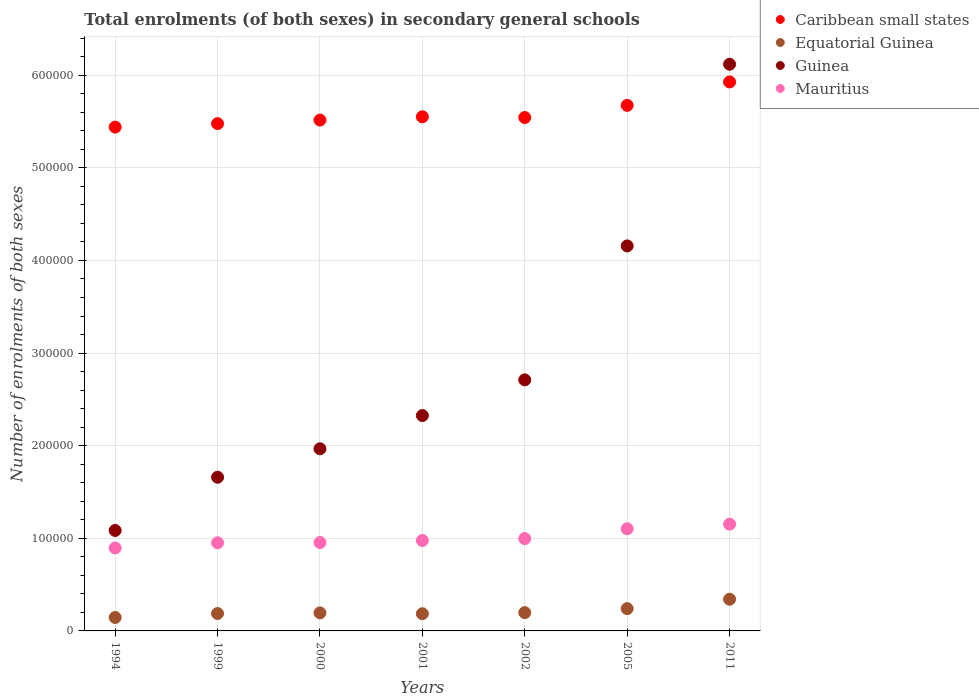How many different coloured dotlines are there?
Offer a terse response. 4. Is the number of dotlines equal to the number of legend labels?
Give a very brief answer. Yes. What is the number of enrolments in secondary schools in Equatorial Guinea in 1994?
Keep it short and to the point. 1.45e+04. Across all years, what is the maximum number of enrolments in secondary schools in Mauritius?
Your answer should be very brief. 1.15e+05. Across all years, what is the minimum number of enrolments in secondary schools in Guinea?
Your answer should be compact. 1.08e+05. What is the total number of enrolments in secondary schools in Equatorial Guinea in the graph?
Your answer should be very brief. 1.49e+05. What is the difference between the number of enrolments in secondary schools in Caribbean small states in 1999 and that in 2002?
Offer a very short reply. -6573.19. What is the difference between the number of enrolments in secondary schools in Mauritius in 2000 and the number of enrolments in secondary schools in Guinea in 2001?
Offer a terse response. -1.37e+05. What is the average number of enrolments in secondary schools in Caribbean small states per year?
Provide a succinct answer. 5.59e+05. In the year 1994, what is the difference between the number of enrolments in secondary schools in Equatorial Guinea and number of enrolments in secondary schools in Mauritius?
Ensure brevity in your answer.  -7.51e+04. In how many years, is the number of enrolments in secondary schools in Guinea greater than 240000?
Your answer should be very brief. 3. What is the ratio of the number of enrolments in secondary schools in Caribbean small states in 2001 to that in 2002?
Your answer should be compact. 1. What is the difference between the highest and the second highest number of enrolments in secondary schools in Mauritius?
Offer a very short reply. 5002. What is the difference between the highest and the lowest number of enrolments in secondary schools in Caribbean small states?
Your answer should be compact. 4.88e+04. Does the number of enrolments in secondary schools in Mauritius monotonically increase over the years?
Provide a short and direct response. Yes. How many dotlines are there?
Provide a succinct answer. 4. What is the difference between two consecutive major ticks on the Y-axis?
Your answer should be very brief. 1.00e+05. Does the graph contain any zero values?
Give a very brief answer. No. Does the graph contain grids?
Offer a terse response. Yes. How many legend labels are there?
Your answer should be compact. 4. How are the legend labels stacked?
Offer a very short reply. Vertical. What is the title of the graph?
Offer a terse response. Total enrolments (of both sexes) in secondary general schools. Does "Middle East & North Africa (all income levels)" appear as one of the legend labels in the graph?
Offer a terse response. No. What is the label or title of the Y-axis?
Ensure brevity in your answer.  Number of enrolments of both sexes. What is the Number of enrolments of both sexes in Caribbean small states in 1994?
Offer a terse response. 5.44e+05. What is the Number of enrolments of both sexes of Equatorial Guinea in 1994?
Ensure brevity in your answer.  1.45e+04. What is the Number of enrolments of both sexes of Guinea in 1994?
Your response must be concise. 1.08e+05. What is the Number of enrolments of both sexes of Mauritius in 1994?
Keep it short and to the point. 8.96e+04. What is the Number of enrolments of both sexes of Caribbean small states in 1999?
Your answer should be compact. 5.48e+05. What is the Number of enrolments of both sexes of Equatorial Guinea in 1999?
Give a very brief answer. 1.88e+04. What is the Number of enrolments of both sexes in Guinea in 1999?
Offer a terse response. 1.66e+05. What is the Number of enrolments of both sexes in Mauritius in 1999?
Make the answer very short. 9.52e+04. What is the Number of enrolments of both sexes of Caribbean small states in 2000?
Offer a very short reply. 5.52e+05. What is the Number of enrolments of both sexes in Equatorial Guinea in 2000?
Give a very brief answer. 1.95e+04. What is the Number of enrolments of both sexes in Guinea in 2000?
Your answer should be very brief. 1.97e+05. What is the Number of enrolments of both sexes in Mauritius in 2000?
Offer a very short reply. 9.54e+04. What is the Number of enrolments of both sexes in Caribbean small states in 2001?
Provide a short and direct response. 5.55e+05. What is the Number of enrolments of both sexes in Equatorial Guinea in 2001?
Your answer should be compact. 1.86e+04. What is the Number of enrolments of both sexes in Guinea in 2001?
Offer a terse response. 2.33e+05. What is the Number of enrolments of both sexes in Mauritius in 2001?
Give a very brief answer. 9.76e+04. What is the Number of enrolments of both sexes in Caribbean small states in 2002?
Offer a very short reply. 5.54e+05. What is the Number of enrolments of both sexes in Equatorial Guinea in 2002?
Your answer should be compact. 1.97e+04. What is the Number of enrolments of both sexes of Guinea in 2002?
Ensure brevity in your answer.  2.71e+05. What is the Number of enrolments of both sexes of Mauritius in 2002?
Your response must be concise. 9.97e+04. What is the Number of enrolments of both sexes of Caribbean small states in 2005?
Give a very brief answer. 5.67e+05. What is the Number of enrolments of both sexes in Equatorial Guinea in 2005?
Provide a succinct answer. 2.41e+04. What is the Number of enrolments of both sexes in Guinea in 2005?
Offer a very short reply. 4.16e+05. What is the Number of enrolments of both sexes of Mauritius in 2005?
Your response must be concise. 1.10e+05. What is the Number of enrolments of both sexes of Caribbean small states in 2011?
Keep it short and to the point. 5.93e+05. What is the Number of enrolments of both sexes of Equatorial Guinea in 2011?
Keep it short and to the point. 3.42e+04. What is the Number of enrolments of both sexes in Guinea in 2011?
Offer a terse response. 6.12e+05. What is the Number of enrolments of both sexes of Mauritius in 2011?
Offer a very short reply. 1.15e+05. Across all years, what is the maximum Number of enrolments of both sexes of Caribbean small states?
Give a very brief answer. 5.93e+05. Across all years, what is the maximum Number of enrolments of both sexes of Equatorial Guinea?
Make the answer very short. 3.42e+04. Across all years, what is the maximum Number of enrolments of both sexes of Guinea?
Offer a very short reply. 6.12e+05. Across all years, what is the maximum Number of enrolments of both sexes of Mauritius?
Provide a succinct answer. 1.15e+05. Across all years, what is the minimum Number of enrolments of both sexes of Caribbean small states?
Offer a very short reply. 5.44e+05. Across all years, what is the minimum Number of enrolments of both sexes in Equatorial Guinea?
Make the answer very short. 1.45e+04. Across all years, what is the minimum Number of enrolments of both sexes in Guinea?
Your answer should be very brief. 1.08e+05. Across all years, what is the minimum Number of enrolments of both sexes in Mauritius?
Ensure brevity in your answer.  8.96e+04. What is the total Number of enrolments of both sexes in Caribbean small states in the graph?
Offer a very short reply. 3.91e+06. What is the total Number of enrolments of both sexes in Equatorial Guinea in the graph?
Provide a succinct answer. 1.49e+05. What is the total Number of enrolments of both sexes of Guinea in the graph?
Give a very brief answer. 2.00e+06. What is the total Number of enrolments of both sexes in Mauritius in the graph?
Give a very brief answer. 7.03e+05. What is the difference between the Number of enrolments of both sexes of Caribbean small states in 1994 and that in 1999?
Your answer should be compact. -3752. What is the difference between the Number of enrolments of both sexes in Equatorial Guinea in 1994 and that in 1999?
Make the answer very short. -4291. What is the difference between the Number of enrolments of both sexes in Guinea in 1994 and that in 1999?
Give a very brief answer. -5.75e+04. What is the difference between the Number of enrolments of both sexes in Mauritius in 1994 and that in 1999?
Your answer should be very brief. -5606. What is the difference between the Number of enrolments of both sexes in Caribbean small states in 1994 and that in 2000?
Offer a terse response. -7582. What is the difference between the Number of enrolments of both sexes in Equatorial Guinea in 1994 and that in 2000?
Offer a terse response. -4972. What is the difference between the Number of enrolments of both sexes in Guinea in 1994 and that in 2000?
Offer a very short reply. -8.82e+04. What is the difference between the Number of enrolments of both sexes of Mauritius in 1994 and that in 2000?
Provide a succinct answer. -5867. What is the difference between the Number of enrolments of both sexes of Caribbean small states in 1994 and that in 2001?
Give a very brief answer. -1.11e+04. What is the difference between the Number of enrolments of both sexes of Equatorial Guinea in 1994 and that in 2001?
Offer a very short reply. -4044. What is the difference between the Number of enrolments of both sexes of Guinea in 1994 and that in 2001?
Your answer should be compact. -1.24e+05. What is the difference between the Number of enrolments of both sexes in Mauritius in 1994 and that in 2001?
Provide a succinct answer. -8066. What is the difference between the Number of enrolments of both sexes in Caribbean small states in 1994 and that in 2002?
Offer a very short reply. -1.03e+04. What is the difference between the Number of enrolments of both sexes of Equatorial Guinea in 1994 and that in 2002?
Give a very brief answer. -5237. What is the difference between the Number of enrolments of both sexes in Guinea in 1994 and that in 2002?
Give a very brief answer. -1.63e+05. What is the difference between the Number of enrolments of both sexes in Mauritius in 1994 and that in 2002?
Your response must be concise. -1.01e+04. What is the difference between the Number of enrolments of both sexes in Caribbean small states in 1994 and that in 2005?
Your answer should be compact. -2.35e+04. What is the difference between the Number of enrolments of both sexes in Equatorial Guinea in 1994 and that in 2005?
Keep it short and to the point. -9553. What is the difference between the Number of enrolments of both sexes of Guinea in 1994 and that in 2005?
Your answer should be very brief. -3.07e+05. What is the difference between the Number of enrolments of both sexes in Mauritius in 1994 and that in 2005?
Provide a succinct answer. -2.07e+04. What is the difference between the Number of enrolments of both sexes in Caribbean small states in 1994 and that in 2011?
Keep it short and to the point. -4.88e+04. What is the difference between the Number of enrolments of both sexes of Equatorial Guinea in 1994 and that in 2011?
Your response must be concise. -1.97e+04. What is the difference between the Number of enrolments of both sexes in Guinea in 1994 and that in 2011?
Provide a succinct answer. -5.03e+05. What is the difference between the Number of enrolments of both sexes in Mauritius in 1994 and that in 2011?
Ensure brevity in your answer.  -2.57e+04. What is the difference between the Number of enrolments of both sexes of Caribbean small states in 1999 and that in 2000?
Provide a short and direct response. -3830. What is the difference between the Number of enrolments of both sexes in Equatorial Guinea in 1999 and that in 2000?
Make the answer very short. -681. What is the difference between the Number of enrolments of both sexes of Guinea in 1999 and that in 2000?
Your response must be concise. -3.07e+04. What is the difference between the Number of enrolments of both sexes of Mauritius in 1999 and that in 2000?
Make the answer very short. -261. What is the difference between the Number of enrolments of both sexes in Caribbean small states in 1999 and that in 2001?
Your answer should be very brief. -7373.25. What is the difference between the Number of enrolments of both sexes of Equatorial Guinea in 1999 and that in 2001?
Give a very brief answer. 247. What is the difference between the Number of enrolments of both sexes in Guinea in 1999 and that in 2001?
Offer a terse response. -6.66e+04. What is the difference between the Number of enrolments of both sexes of Mauritius in 1999 and that in 2001?
Offer a very short reply. -2460. What is the difference between the Number of enrolments of both sexes in Caribbean small states in 1999 and that in 2002?
Provide a short and direct response. -6573.19. What is the difference between the Number of enrolments of both sexes of Equatorial Guinea in 1999 and that in 2002?
Make the answer very short. -946. What is the difference between the Number of enrolments of both sexes of Guinea in 1999 and that in 2002?
Offer a very short reply. -1.05e+05. What is the difference between the Number of enrolments of both sexes in Mauritius in 1999 and that in 2002?
Your response must be concise. -4500. What is the difference between the Number of enrolments of both sexes in Caribbean small states in 1999 and that in 2005?
Make the answer very short. -1.97e+04. What is the difference between the Number of enrolments of both sexes in Equatorial Guinea in 1999 and that in 2005?
Your response must be concise. -5262. What is the difference between the Number of enrolments of both sexes in Guinea in 1999 and that in 2005?
Ensure brevity in your answer.  -2.50e+05. What is the difference between the Number of enrolments of both sexes of Mauritius in 1999 and that in 2005?
Make the answer very short. -1.51e+04. What is the difference between the Number of enrolments of both sexes in Caribbean small states in 1999 and that in 2011?
Ensure brevity in your answer.  -4.50e+04. What is the difference between the Number of enrolments of both sexes in Equatorial Guinea in 1999 and that in 2011?
Provide a succinct answer. -1.54e+04. What is the difference between the Number of enrolments of both sexes of Guinea in 1999 and that in 2011?
Offer a terse response. -4.46e+05. What is the difference between the Number of enrolments of both sexes in Mauritius in 1999 and that in 2011?
Provide a short and direct response. -2.01e+04. What is the difference between the Number of enrolments of both sexes in Caribbean small states in 2000 and that in 2001?
Your answer should be compact. -3543.25. What is the difference between the Number of enrolments of both sexes of Equatorial Guinea in 2000 and that in 2001?
Provide a succinct answer. 928. What is the difference between the Number of enrolments of both sexes in Guinea in 2000 and that in 2001?
Provide a succinct answer. -3.59e+04. What is the difference between the Number of enrolments of both sexes of Mauritius in 2000 and that in 2001?
Give a very brief answer. -2199. What is the difference between the Number of enrolments of both sexes in Caribbean small states in 2000 and that in 2002?
Make the answer very short. -2743.19. What is the difference between the Number of enrolments of both sexes in Equatorial Guinea in 2000 and that in 2002?
Keep it short and to the point. -265. What is the difference between the Number of enrolments of both sexes of Guinea in 2000 and that in 2002?
Offer a very short reply. -7.44e+04. What is the difference between the Number of enrolments of both sexes in Mauritius in 2000 and that in 2002?
Your response must be concise. -4239. What is the difference between the Number of enrolments of both sexes in Caribbean small states in 2000 and that in 2005?
Make the answer very short. -1.59e+04. What is the difference between the Number of enrolments of both sexes in Equatorial Guinea in 2000 and that in 2005?
Your response must be concise. -4581. What is the difference between the Number of enrolments of both sexes in Guinea in 2000 and that in 2005?
Give a very brief answer. -2.19e+05. What is the difference between the Number of enrolments of both sexes in Mauritius in 2000 and that in 2005?
Offer a very short reply. -1.48e+04. What is the difference between the Number of enrolments of both sexes of Caribbean small states in 2000 and that in 2011?
Offer a terse response. -4.12e+04. What is the difference between the Number of enrolments of both sexes in Equatorial Guinea in 2000 and that in 2011?
Keep it short and to the point. -1.48e+04. What is the difference between the Number of enrolments of both sexes of Guinea in 2000 and that in 2011?
Keep it short and to the point. -4.15e+05. What is the difference between the Number of enrolments of both sexes of Mauritius in 2000 and that in 2011?
Your answer should be compact. -1.98e+04. What is the difference between the Number of enrolments of both sexes of Caribbean small states in 2001 and that in 2002?
Provide a succinct answer. 800.06. What is the difference between the Number of enrolments of both sexes in Equatorial Guinea in 2001 and that in 2002?
Offer a very short reply. -1193. What is the difference between the Number of enrolments of both sexes in Guinea in 2001 and that in 2002?
Your response must be concise. -3.85e+04. What is the difference between the Number of enrolments of both sexes in Mauritius in 2001 and that in 2002?
Keep it short and to the point. -2040. What is the difference between the Number of enrolments of both sexes of Caribbean small states in 2001 and that in 2005?
Keep it short and to the point. -1.23e+04. What is the difference between the Number of enrolments of both sexes of Equatorial Guinea in 2001 and that in 2005?
Your response must be concise. -5509. What is the difference between the Number of enrolments of both sexes in Guinea in 2001 and that in 2005?
Make the answer very short. -1.83e+05. What is the difference between the Number of enrolments of both sexes in Mauritius in 2001 and that in 2005?
Give a very brief answer. -1.26e+04. What is the difference between the Number of enrolments of both sexes in Caribbean small states in 2001 and that in 2011?
Your response must be concise. -3.77e+04. What is the difference between the Number of enrolments of both sexes in Equatorial Guinea in 2001 and that in 2011?
Give a very brief answer. -1.57e+04. What is the difference between the Number of enrolments of both sexes in Guinea in 2001 and that in 2011?
Offer a terse response. -3.79e+05. What is the difference between the Number of enrolments of both sexes in Mauritius in 2001 and that in 2011?
Make the answer very short. -1.76e+04. What is the difference between the Number of enrolments of both sexes in Caribbean small states in 2002 and that in 2005?
Your answer should be compact. -1.31e+04. What is the difference between the Number of enrolments of both sexes of Equatorial Guinea in 2002 and that in 2005?
Your answer should be compact. -4316. What is the difference between the Number of enrolments of both sexes of Guinea in 2002 and that in 2005?
Your answer should be compact. -1.45e+05. What is the difference between the Number of enrolments of both sexes of Mauritius in 2002 and that in 2005?
Offer a very short reply. -1.06e+04. What is the difference between the Number of enrolments of both sexes of Caribbean small states in 2002 and that in 2011?
Your response must be concise. -3.85e+04. What is the difference between the Number of enrolments of both sexes in Equatorial Guinea in 2002 and that in 2011?
Offer a terse response. -1.45e+04. What is the difference between the Number of enrolments of both sexes in Guinea in 2002 and that in 2011?
Your answer should be compact. -3.41e+05. What is the difference between the Number of enrolments of both sexes of Mauritius in 2002 and that in 2011?
Your answer should be compact. -1.56e+04. What is the difference between the Number of enrolments of both sexes in Caribbean small states in 2005 and that in 2011?
Your answer should be very brief. -2.53e+04. What is the difference between the Number of enrolments of both sexes in Equatorial Guinea in 2005 and that in 2011?
Provide a succinct answer. -1.02e+04. What is the difference between the Number of enrolments of both sexes of Guinea in 2005 and that in 2011?
Provide a succinct answer. -1.96e+05. What is the difference between the Number of enrolments of both sexes in Mauritius in 2005 and that in 2011?
Your answer should be compact. -5002. What is the difference between the Number of enrolments of both sexes of Caribbean small states in 1994 and the Number of enrolments of both sexes of Equatorial Guinea in 1999?
Offer a very short reply. 5.25e+05. What is the difference between the Number of enrolments of both sexes of Caribbean small states in 1994 and the Number of enrolments of both sexes of Guinea in 1999?
Provide a succinct answer. 3.78e+05. What is the difference between the Number of enrolments of both sexes of Caribbean small states in 1994 and the Number of enrolments of both sexes of Mauritius in 1999?
Ensure brevity in your answer.  4.49e+05. What is the difference between the Number of enrolments of both sexes in Equatorial Guinea in 1994 and the Number of enrolments of both sexes in Guinea in 1999?
Provide a short and direct response. -1.51e+05. What is the difference between the Number of enrolments of both sexes of Equatorial Guinea in 1994 and the Number of enrolments of both sexes of Mauritius in 1999?
Provide a succinct answer. -8.07e+04. What is the difference between the Number of enrolments of both sexes of Guinea in 1994 and the Number of enrolments of both sexes of Mauritius in 1999?
Provide a succinct answer. 1.33e+04. What is the difference between the Number of enrolments of both sexes of Caribbean small states in 1994 and the Number of enrolments of both sexes of Equatorial Guinea in 2000?
Offer a terse response. 5.25e+05. What is the difference between the Number of enrolments of both sexes in Caribbean small states in 1994 and the Number of enrolments of both sexes in Guinea in 2000?
Offer a very short reply. 3.47e+05. What is the difference between the Number of enrolments of both sexes of Caribbean small states in 1994 and the Number of enrolments of both sexes of Mauritius in 2000?
Provide a succinct answer. 4.49e+05. What is the difference between the Number of enrolments of both sexes of Equatorial Guinea in 1994 and the Number of enrolments of both sexes of Guinea in 2000?
Offer a very short reply. -1.82e+05. What is the difference between the Number of enrolments of both sexes in Equatorial Guinea in 1994 and the Number of enrolments of both sexes in Mauritius in 2000?
Provide a short and direct response. -8.09e+04. What is the difference between the Number of enrolments of both sexes in Guinea in 1994 and the Number of enrolments of both sexes in Mauritius in 2000?
Your answer should be compact. 1.30e+04. What is the difference between the Number of enrolments of both sexes in Caribbean small states in 1994 and the Number of enrolments of both sexes in Equatorial Guinea in 2001?
Offer a terse response. 5.25e+05. What is the difference between the Number of enrolments of both sexes in Caribbean small states in 1994 and the Number of enrolments of both sexes in Guinea in 2001?
Provide a succinct answer. 3.11e+05. What is the difference between the Number of enrolments of both sexes of Caribbean small states in 1994 and the Number of enrolments of both sexes of Mauritius in 2001?
Provide a short and direct response. 4.46e+05. What is the difference between the Number of enrolments of both sexes of Equatorial Guinea in 1994 and the Number of enrolments of both sexes of Guinea in 2001?
Provide a succinct answer. -2.18e+05. What is the difference between the Number of enrolments of both sexes in Equatorial Guinea in 1994 and the Number of enrolments of both sexes in Mauritius in 2001?
Offer a very short reply. -8.31e+04. What is the difference between the Number of enrolments of both sexes of Guinea in 1994 and the Number of enrolments of both sexes of Mauritius in 2001?
Give a very brief answer. 1.08e+04. What is the difference between the Number of enrolments of both sexes in Caribbean small states in 1994 and the Number of enrolments of both sexes in Equatorial Guinea in 2002?
Your answer should be very brief. 5.24e+05. What is the difference between the Number of enrolments of both sexes of Caribbean small states in 1994 and the Number of enrolments of both sexes of Guinea in 2002?
Ensure brevity in your answer.  2.73e+05. What is the difference between the Number of enrolments of both sexes in Caribbean small states in 1994 and the Number of enrolments of both sexes in Mauritius in 2002?
Give a very brief answer. 4.44e+05. What is the difference between the Number of enrolments of both sexes of Equatorial Guinea in 1994 and the Number of enrolments of both sexes of Guinea in 2002?
Provide a short and direct response. -2.57e+05. What is the difference between the Number of enrolments of both sexes in Equatorial Guinea in 1994 and the Number of enrolments of both sexes in Mauritius in 2002?
Keep it short and to the point. -8.52e+04. What is the difference between the Number of enrolments of both sexes in Guinea in 1994 and the Number of enrolments of both sexes in Mauritius in 2002?
Make the answer very short. 8772. What is the difference between the Number of enrolments of both sexes of Caribbean small states in 1994 and the Number of enrolments of both sexes of Equatorial Guinea in 2005?
Ensure brevity in your answer.  5.20e+05. What is the difference between the Number of enrolments of both sexes in Caribbean small states in 1994 and the Number of enrolments of both sexes in Guinea in 2005?
Keep it short and to the point. 1.28e+05. What is the difference between the Number of enrolments of both sexes in Caribbean small states in 1994 and the Number of enrolments of both sexes in Mauritius in 2005?
Make the answer very short. 4.34e+05. What is the difference between the Number of enrolments of both sexes of Equatorial Guinea in 1994 and the Number of enrolments of both sexes of Guinea in 2005?
Your response must be concise. -4.01e+05. What is the difference between the Number of enrolments of both sexes in Equatorial Guinea in 1994 and the Number of enrolments of both sexes in Mauritius in 2005?
Make the answer very short. -9.58e+04. What is the difference between the Number of enrolments of both sexes of Guinea in 1994 and the Number of enrolments of both sexes of Mauritius in 2005?
Ensure brevity in your answer.  -1828. What is the difference between the Number of enrolments of both sexes of Caribbean small states in 1994 and the Number of enrolments of both sexes of Equatorial Guinea in 2011?
Ensure brevity in your answer.  5.10e+05. What is the difference between the Number of enrolments of both sexes of Caribbean small states in 1994 and the Number of enrolments of both sexes of Guinea in 2011?
Provide a short and direct response. -6.79e+04. What is the difference between the Number of enrolments of both sexes in Caribbean small states in 1994 and the Number of enrolments of both sexes in Mauritius in 2011?
Provide a short and direct response. 4.29e+05. What is the difference between the Number of enrolments of both sexes in Equatorial Guinea in 1994 and the Number of enrolments of both sexes in Guinea in 2011?
Offer a terse response. -5.97e+05. What is the difference between the Number of enrolments of both sexes of Equatorial Guinea in 1994 and the Number of enrolments of both sexes of Mauritius in 2011?
Ensure brevity in your answer.  -1.01e+05. What is the difference between the Number of enrolments of both sexes of Guinea in 1994 and the Number of enrolments of both sexes of Mauritius in 2011?
Make the answer very short. -6830. What is the difference between the Number of enrolments of both sexes of Caribbean small states in 1999 and the Number of enrolments of both sexes of Equatorial Guinea in 2000?
Give a very brief answer. 5.28e+05. What is the difference between the Number of enrolments of both sexes in Caribbean small states in 1999 and the Number of enrolments of both sexes in Guinea in 2000?
Give a very brief answer. 3.51e+05. What is the difference between the Number of enrolments of both sexes in Caribbean small states in 1999 and the Number of enrolments of both sexes in Mauritius in 2000?
Offer a very short reply. 4.52e+05. What is the difference between the Number of enrolments of both sexes in Equatorial Guinea in 1999 and the Number of enrolments of both sexes in Guinea in 2000?
Ensure brevity in your answer.  -1.78e+05. What is the difference between the Number of enrolments of both sexes in Equatorial Guinea in 1999 and the Number of enrolments of both sexes in Mauritius in 2000?
Offer a very short reply. -7.66e+04. What is the difference between the Number of enrolments of both sexes in Guinea in 1999 and the Number of enrolments of both sexes in Mauritius in 2000?
Keep it short and to the point. 7.05e+04. What is the difference between the Number of enrolments of both sexes in Caribbean small states in 1999 and the Number of enrolments of both sexes in Equatorial Guinea in 2001?
Ensure brevity in your answer.  5.29e+05. What is the difference between the Number of enrolments of both sexes in Caribbean small states in 1999 and the Number of enrolments of both sexes in Guinea in 2001?
Provide a short and direct response. 3.15e+05. What is the difference between the Number of enrolments of both sexes in Caribbean small states in 1999 and the Number of enrolments of both sexes in Mauritius in 2001?
Ensure brevity in your answer.  4.50e+05. What is the difference between the Number of enrolments of both sexes in Equatorial Guinea in 1999 and the Number of enrolments of both sexes in Guinea in 2001?
Offer a very short reply. -2.14e+05. What is the difference between the Number of enrolments of both sexes of Equatorial Guinea in 1999 and the Number of enrolments of both sexes of Mauritius in 2001?
Provide a short and direct response. -7.88e+04. What is the difference between the Number of enrolments of both sexes of Guinea in 1999 and the Number of enrolments of both sexes of Mauritius in 2001?
Offer a very short reply. 6.83e+04. What is the difference between the Number of enrolments of both sexes of Caribbean small states in 1999 and the Number of enrolments of both sexes of Equatorial Guinea in 2002?
Offer a very short reply. 5.28e+05. What is the difference between the Number of enrolments of both sexes of Caribbean small states in 1999 and the Number of enrolments of both sexes of Guinea in 2002?
Your response must be concise. 2.77e+05. What is the difference between the Number of enrolments of both sexes in Caribbean small states in 1999 and the Number of enrolments of both sexes in Mauritius in 2002?
Your answer should be compact. 4.48e+05. What is the difference between the Number of enrolments of both sexes in Equatorial Guinea in 1999 and the Number of enrolments of both sexes in Guinea in 2002?
Ensure brevity in your answer.  -2.52e+05. What is the difference between the Number of enrolments of both sexes of Equatorial Guinea in 1999 and the Number of enrolments of both sexes of Mauritius in 2002?
Your answer should be very brief. -8.09e+04. What is the difference between the Number of enrolments of both sexes in Guinea in 1999 and the Number of enrolments of both sexes in Mauritius in 2002?
Provide a succinct answer. 6.62e+04. What is the difference between the Number of enrolments of both sexes of Caribbean small states in 1999 and the Number of enrolments of both sexes of Equatorial Guinea in 2005?
Your answer should be very brief. 5.24e+05. What is the difference between the Number of enrolments of both sexes of Caribbean small states in 1999 and the Number of enrolments of both sexes of Guinea in 2005?
Offer a terse response. 1.32e+05. What is the difference between the Number of enrolments of both sexes of Caribbean small states in 1999 and the Number of enrolments of both sexes of Mauritius in 2005?
Make the answer very short. 4.37e+05. What is the difference between the Number of enrolments of both sexes of Equatorial Guinea in 1999 and the Number of enrolments of both sexes of Guinea in 2005?
Make the answer very short. -3.97e+05. What is the difference between the Number of enrolments of both sexes in Equatorial Guinea in 1999 and the Number of enrolments of both sexes in Mauritius in 2005?
Offer a very short reply. -9.15e+04. What is the difference between the Number of enrolments of both sexes of Guinea in 1999 and the Number of enrolments of both sexes of Mauritius in 2005?
Ensure brevity in your answer.  5.56e+04. What is the difference between the Number of enrolments of both sexes in Caribbean small states in 1999 and the Number of enrolments of both sexes in Equatorial Guinea in 2011?
Your response must be concise. 5.14e+05. What is the difference between the Number of enrolments of both sexes of Caribbean small states in 1999 and the Number of enrolments of both sexes of Guinea in 2011?
Provide a succinct answer. -6.41e+04. What is the difference between the Number of enrolments of both sexes of Caribbean small states in 1999 and the Number of enrolments of both sexes of Mauritius in 2011?
Your answer should be compact. 4.32e+05. What is the difference between the Number of enrolments of both sexes of Equatorial Guinea in 1999 and the Number of enrolments of both sexes of Guinea in 2011?
Your answer should be very brief. -5.93e+05. What is the difference between the Number of enrolments of both sexes of Equatorial Guinea in 1999 and the Number of enrolments of both sexes of Mauritius in 2011?
Your answer should be very brief. -9.65e+04. What is the difference between the Number of enrolments of both sexes of Guinea in 1999 and the Number of enrolments of both sexes of Mauritius in 2011?
Provide a short and direct response. 5.06e+04. What is the difference between the Number of enrolments of both sexes of Caribbean small states in 2000 and the Number of enrolments of both sexes of Equatorial Guinea in 2001?
Provide a succinct answer. 5.33e+05. What is the difference between the Number of enrolments of both sexes in Caribbean small states in 2000 and the Number of enrolments of both sexes in Guinea in 2001?
Your response must be concise. 3.19e+05. What is the difference between the Number of enrolments of both sexes in Caribbean small states in 2000 and the Number of enrolments of both sexes in Mauritius in 2001?
Keep it short and to the point. 4.54e+05. What is the difference between the Number of enrolments of both sexes in Equatorial Guinea in 2000 and the Number of enrolments of both sexes in Guinea in 2001?
Your response must be concise. -2.13e+05. What is the difference between the Number of enrolments of both sexes of Equatorial Guinea in 2000 and the Number of enrolments of both sexes of Mauritius in 2001?
Make the answer very short. -7.82e+04. What is the difference between the Number of enrolments of both sexes of Guinea in 2000 and the Number of enrolments of both sexes of Mauritius in 2001?
Ensure brevity in your answer.  9.90e+04. What is the difference between the Number of enrolments of both sexes in Caribbean small states in 2000 and the Number of enrolments of both sexes in Equatorial Guinea in 2002?
Keep it short and to the point. 5.32e+05. What is the difference between the Number of enrolments of both sexes in Caribbean small states in 2000 and the Number of enrolments of both sexes in Guinea in 2002?
Provide a succinct answer. 2.80e+05. What is the difference between the Number of enrolments of both sexes of Caribbean small states in 2000 and the Number of enrolments of both sexes of Mauritius in 2002?
Your answer should be compact. 4.52e+05. What is the difference between the Number of enrolments of both sexes of Equatorial Guinea in 2000 and the Number of enrolments of both sexes of Guinea in 2002?
Keep it short and to the point. -2.52e+05. What is the difference between the Number of enrolments of both sexes of Equatorial Guinea in 2000 and the Number of enrolments of both sexes of Mauritius in 2002?
Provide a succinct answer. -8.02e+04. What is the difference between the Number of enrolments of both sexes in Guinea in 2000 and the Number of enrolments of both sexes in Mauritius in 2002?
Keep it short and to the point. 9.70e+04. What is the difference between the Number of enrolments of both sexes of Caribbean small states in 2000 and the Number of enrolments of both sexes of Equatorial Guinea in 2005?
Keep it short and to the point. 5.28e+05. What is the difference between the Number of enrolments of both sexes of Caribbean small states in 2000 and the Number of enrolments of both sexes of Guinea in 2005?
Your answer should be very brief. 1.36e+05. What is the difference between the Number of enrolments of both sexes in Caribbean small states in 2000 and the Number of enrolments of both sexes in Mauritius in 2005?
Your response must be concise. 4.41e+05. What is the difference between the Number of enrolments of both sexes in Equatorial Guinea in 2000 and the Number of enrolments of both sexes in Guinea in 2005?
Your answer should be compact. -3.96e+05. What is the difference between the Number of enrolments of both sexes in Equatorial Guinea in 2000 and the Number of enrolments of both sexes in Mauritius in 2005?
Provide a short and direct response. -9.08e+04. What is the difference between the Number of enrolments of both sexes in Guinea in 2000 and the Number of enrolments of both sexes in Mauritius in 2005?
Provide a short and direct response. 8.64e+04. What is the difference between the Number of enrolments of both sexes of Caribbean small states in 2000 and the Number of enrolments of both sexes of Equatorial Guinea in 2011?
Provide a succinct answer. 5.17e+05. What is the difference between the Number of enrolments of both sexes of Caribbean small states in 2000 and the Number of enrolments of both sexes of Guinea in 2011?
Provide a short and direct response. -6.03e+04. What is the difference between the Number of enrolments of both sexes of Caribbean small states in 2000 and the Number of enrolments of both sexes of Mauritius in 2011?
Your answer should be compact. 4.36e+05. What is the difference between the Number of enrolments of both sexes in Equatorial Guinea in 2000 and the Number of enrolments of both sexes in Guinea in 2011?
Provide a short and direct response. -5.92e+05. What is the difference between the Number of enrolments of both sexes in Equatorial Guinea in 2000 and the Number of enrolments of both sexes in Mauritius in 2011?
Offer a terse response. -9.58e+04. What is the difference between the Number of enrolments of both sexes in Guinea in 2000 and the Number of enrolments of both sexes in Mauritius in 2011?
Offer a very short reply. 8.14e+04. What is the difference between the Number of enrolments of both sexes of Caribbean small states in 2001 and the Number of enrolments of both sexes of Equatorial Guinea in 2002?
Your answer should be very brief. 5.35e+05. What is the difference between the Number of enrolments of both sexes in Caribbean small states in 2001 and the Number of enrolments of both sexes in Guinea in 2002?
Make the answer very short. 2.84e+05. What is the difference between the Number of enrolments of both sexes in Caribbean small states in 2001 and the Number of enrolments of both sexes in Mauritius in 2002?
Provide a short and direct response. 4.55e+05. What is the difference between the Number of enrolments of both sexes in Equatorial Guinea in 2001 and the Number of enrolments of both sexes in Guinea in 2002?
Provide a succinct answer. -2.53e+05. What is the difference between the Number of enrolments of both sexes of Equatorial Guinea in 2001 and the Number of enrolments of both sexes of Mauritius in 2002?
Offer a terse response. -8.11e+04. What is the difference between the Number of enrolments of both sexes of Guinea in 2001 and the Number of enrolments of both sexes of Mauritius in 2002?
Provide a succinct answer. 1.33e+05. What is the difference between the Number of enrolments of both sexes in Caribbean small states in 2001 and the Number of enrolments of both sexes in Equatorial Guinea in 2005?
Give a very brief answer. 5.31e+05. What is the difference between the Number of enrolments of both sexes in Caribbean small states in 2001 and the Number of enrolments of both sexes in Guinea in 2005?
Offer a very short reply. 1.39e+05. What is the difference between the Number of enrolments of both sexes of Caribbean small states in 2001 and the Number of enrolments of both sexes of Mauritius in 2005?
Ensure brevity in your answer.  4.45e+05. What is the difference between the Number of enrolments of both sexes in Equatorial Guinea in 2001 and the Number of enrolments of both sexes in Guinea in 2005?
Keep it short and to the point. -3.97e+05. What is the difference between the Number of enrolments of both sexes in Equatorial Guinea in 2001 and the Number of enrolments of both sexes in Mauritius in 2005?
Ensure brevity in your answer.  -9.17e+04. What is the difference between the Number of enrolments of both sexes in Guinea in 2001 and the Number of enrolments of both sexes in Mauritius in 2005?
Offer a terse response. 1.22e+05. What is the difference between the Number of enrolments of both sexes in Caribbean small states in 2001 and the Number of enrolments of both sexes in Equatorial Guinea in 2011?
Ensure brevity in your answer.  5.21e+05. What is the difference between the Number of enrolments of both sexes in Caribbean small states in 2001 and the Number of enrolments of both sexes in Guinea in 2011?
Offer a very short reply. -5.67e+04. What is the difference between the Number of enrolments of both sexes of Caribbean small states in 2001 and the Number of enrolments of both sexes of Mauritius in 2011?
Ensure brevity in your answer.  4.40e+05. What is the difference between the Number of enrolments of both sexes in Equatorial Guinea in 2001 and the Number of enrolments of both sexes in Guinea in 2011?
Offer a very short reply. -5.93e+05. What is the difference between the Number of enrolments of both sexes of Equatorial Guinea in 2001 and the Number of enrolments of both sexes of Mauritius in 2011?
Your response must be concise. -9.67e+04. What is the difference between the Number of enrolments of both sexes of Guinea in 2001 and the Number of enrolments of both sexes of Mauritius in 2011?
Provide a short and direct response. 1.17e+05. What is the difference between the Number of enrolments of both sexes in Caribbean small states in 2002 and the Number of enrolments of both sexes in Equatorial Guinea in 2005?
Offer a very short reply. 5.30e+05. What is the difference between the Number of enrolments of both sexes in Caribbean small states in 2002 and the Number of enrolments of both sexes in Guinea in 2005?
Your answer should be compact. 1.39e+05. What is the difference between the Number of enrolments of both sexes in Caribbean small states in 2002 and the Number of enrolments of both sexes in Mauritius in 2005?
Offer a terse response. 4.44e+05. What is the difference between the Number of enrolments of both sexes in Equatorial Guinea in 2002 and the Number of enrolments of both sexes in Guinea in 2005?
Give a very brief answer. -3.96e+05. What is the difference between the Number of enrolments of both sexes in Equatorial Guinea in 2002 and the Number of enrolments of both sexes in Mauritius in 2005?
Make the answer very short. -9.05e+04. What is the difference between the Number of enrolments of both sexes in Guinea in 2002 and the Number of enrolments of both sexes in Mauritius in 2005?
Make the answer very short. 1.61e+05. What is the difference between the Number of enrolments of both sexes of Caribbean small states in 2002 and the Number of enrolments of both sexes of Equatorial Guinea in 2011?
Make the answer very short. 5.20e+05. What is the difference between the Number of enrolments of both sexes of Caribbean small states in 2002 and the Number of enrolments of both sexes of Guinea in 2011?
Make the answer very short. -5.76e+04. What is the difference between the Number of enrolments of both sexes in Caribbean small states in 2002 and the Number of enrolments of both sexes in Mauritius in 2011?
Offer a terse response. 4.39e+05. What is the difference between the Number of enrolments of both sexes in Equatorial Guinea in 2002 and the Number of enrolments of both sexes in Guinea in 2011?
Make the answer very short. -5.92e+05. What is the difference between the Number of enrolments of both sexes of Equatorial Guinea in 2002 and the Number of enrolments of both sexes of Mauritius in 2011?
Your answer should be very brief. -9.55e+04. What is the difference between the Number of enrolments of both sexes of Guinea in 2002 and the Number of enrolments of both sexes of Mauritius in 2011?
Offer a terse response. 1.56e+05. What is the difference between the Number of enrolments of both sexes in Caribbean small states in 2005 and the Number of enrolments of both sexes in Equatorial Guinea in 2011?
Your answer should be compact. 5.33e+05. What is the difference between the Number of enrolments of both sexes in Caribbean small states in 2005 and the Number of enrolments of both sexes in Guinea in 2011?
Provide a succinct answer. -4.44e+04. What is the difference between the Number of enrolments of both sexes in Caribbean small states in 2005 and the Number of enrolments of both sexes in Mauritius in 2011?
Your answer should be compact. 4.52e+05. What is the difference between the Number of enrolments of both sexes of Equatorial Guinea in 2005 and the Number of enrolments of both sexes of Guinea in 2011?
Give a very brief answer. -5.88e+05. What is the difference between the Number of enrolments of both sexes in Equatorial Guinea in 2005 and the Number of enrolments of both sexes in Mauritius in 2011?
Provide a succinct answer. -9.12e+04. What is the difference between the Number of enrolments of both sexes of Guinea in 2005 and the Number of enrolments of both sexes of Mauritius in 2011?
Keep it short and to the point. 3.00e+05. What is the average Number of enrolments of both sexes of Caribbean small states per year?
Your answer should be very brief. 5.59e+05. What is the average Number of enrolments of both sexes in Equatorial Guinea per year?
Provide a short and direct response. 2.13e+04. What is the average Number of enrolments of both sexes in Guinea per year?
Offer a terse response. 2.86e+05. What is the average Number of enrolments of both sexes in Mauritius per year?
Give a very brief answer. 1.00e+05. In the year 1994, what is the difference between the Number of enrolments of both sexes in Caribbean small states and Number of enrolments of both sexes in Equatorial Guinea?
Offer a terse response. 5.29e+05. In the year 1994, what is the difference between the Number of enrolments of both sexes in Caribbean small states and Number of enrolments of both sexes in Guinea?
Provide a short and direct response. 4.36e+05. In the year 1994, what is the difference between the Number of enrolments of both sexes of Caribbean small states and Number of enrolments of both sexes of Mauritius?
Make the answer very short. 4.54e+05. In the year 1994, what is the difference between the Number of enrolments of both sexes of Equatorial Guinea and Number of enrolments of both sexes of Guinea?
Offer a terse response. -9.39e+04. In the year 1994, what is the difference between the Number of enrolments of both sexes in Equatorial Guinea and Number of enrolments of both sexes in Mauritius?
Offer a very short reply. -7.51e+04. In the year 1994, what is the difference between the Number of enrolments of both sexes of Guinea and Number of enrolments of both sexes of Mauritius?
Ensure brevity in your answer.  1.89e+04. In the year 1999, what is the difference between the Number of enrolments of both sexes of Caribbean small states and Number of enrolments of both sexes of Equatorial Guinea?
Give a very brief answer. 5.29e+05. In the year 1999, what is the difference between the Number of enrolments of both sexes of Caribbean small states and Number of enrolments of both sexes of Guinea?
Your answer should be very brief. 3.82e+05. In the year 1999, what is the difference between the Number of enrolments of both sexes of Caribbean small states and Number of enrolments of both sexes of Mauritius?
Give a very brief answer. 4.53e+05. In the year 1999, what is the difference between the Number of enrolments of both sexes of Equatorial Guinea and Number of enrolments of both sexes of Guinea?
Offer a terse response. -1.47e+05. In the year 1999, what is the difference between the Number of enrolments of both sexes in Equatorial Guinea and Number of enrolments of both sexes in Mauritius?
Your answer should be very brief. -7.64e+04. In the year 1999, what is the difference between the Number of enrolments of both sexes in Guinea and Number of enrolments of both sexes in Mauritius?
Your answer should be compact. 7.07e+04. In the year 2000, what is the difference between the Number of enrolments of both sexes of Caribbean small states and Number of enrolments of both sexes of Equatorial Guinea?
Your answer should be compact. 5.32e+05. In the year 2000, what is the difference between the Number of enrolments of both sexes in Caribbean small states and Number of enrolments of both sexes in Guinea?
Provide a short and direct response. 3.55e+05. In the year 2000, what is the difference between the Number of enrolments of both sexes of Caribbean small states and Number of enrolments of both sexes of Mauritius?
Make the answer very short. 4.56e+05. In the year 2000, what is the difference between the Number of enrolments of both sexes of Equatorial Guinea and Number of enrolments of both sexes of Guinea?
Make the answer very short. -1.77e+05. In the year 2000, what is the difference between the Number of enrolments of both sexes in Equatorial Guinea and Number of enrolments of both sexes in Mauritius?
Give a very brief answer. -7.60e+04. In the year 2000, what is the difference between the Number of enrolments of both sexes of Guinea and Number of enrolments of both sexes of Mauritius?
Give a very brief answer. 1.01e+05. In the year 2001, what is the difference between the Number of enrolments of both sexes of Caribbean small states and Number of enrolments of both sexes of Equatorial Guinea?
Provide a short and direct response. 5.37e+05. In the year 2001, what is the difference between the Number of enrolments of both sexes in Caribbean small states and Number of enrolments of both sexes in Guinea?
Provide a short and direct response. 3.23e+05. In the year 2001, what is the difference between the Number of enrolments of both sexes of Caribbean small states and Number of enrolments of both sexes of Mauritius?
Offer a terse response. 4.57e+05. In the year 2001, what is the difference between the Number of enrolments of both sexes of Equatorial Guinea and Number of enrolments of both sexes of Guinea?
Your answer should be compact. -2.14e+05. In the year 2001, what is the difference between the Number of enrolments of both sexes of Equatorial Guinea and Number of enrolments of both sexes of Mauritius?
Provide a short and direct response. -7.91e+04. In the year 2001, what is the difference between the Number of enrolments of both sexes in Guinea and Number of enrolments of both sexes in Mauritius?
Ensure brevity in your answer.  1.35e+05. In the year 2002, what is the difference between the Number of enrolments of both sexes of Caribbean small states and Number of enrolments of both sexes of Equatorial Guinea?
Provide a succinct answer. 5.35e+05. In the year 2002, what is the difference between the Number of enrolments of both sexes of Caribbean small states and Number of enrolments of both sexes of Guinea?
Give a very brief answer. 2.83e+05. In the year 2002, what is the difference between the Number of enrolments of both sexes of Caribbean small states and Number of enrolments of both sexes of Mauritius?
Make the answer very short. 4.55e+05. In the year 2002, what is the difference between the Number of enrolments of both sexes of Equatorial Guinea and Number of enrolments of both sexes of Guinea?
Your response must be concise. -2.51e+05. In the year 2002, what is the difference between the Number of enrolments of both sexes in Equatorial Guinea and Number of enrolments of both sexes in Mauritius?
Your response must be concise. -7.99e+04. In the year 2002, what is the difference between the Number of enrolments of both sexes in Guinea and Number of enrolments of both sexes in Mauritius?
Your answer should be compact. 1.71e+05. In the year 2005, what is the difference between the Number of enrolments of both sexes of Caribbean small states and Number of enrolments of both sexes of Equatorial Guinea?
Your response must be concise. 5.43e+05. In the year 2005, what is the difference between the Number of enrolments of both sexes of Caribbean small states and Number of enrolments of both sexes of Guinea?
Offer a very short reply. 1.52e+05. In the year 2005, what is the difference between the Number of enrolments of both sexes in Caribbean small states and Number of enrolments of both sexes in Mauritius?
Make the answer very short. 4.57e+05. In the year 2005, what is the difference between the Number of enrolments of both sexes of Equatorial Guinea and Number of enrolments of both sexes of Guinea?
Your answer should be very brief. -3.92e+05. In the year 2005, what is the difference between the Number of enrolments of both sexes in Equatorial Guinea and Number of enrolments of both sexes in Mauritius?
Provide a succinct answer. -8.62e+04. In the year 2005, what is the difference between the Number of enrolments of both sexes in Guinea and Number of enrolments of both sexes in Mauritius?
Offer a terse response. 3.05e+05. In the year 2011, what is the difference between the Number of enrolments of both sexes in Caribbean small states and Number of enrolments of both sexes in Equatorial Guinea?
Give a very brief answer. 5.59e+05. In the year 2011, what is the difference between the Number of enrolments of both sexes in Caribbean small states and Number of enrolments of both sexes in Guinea?
Offer a very short reply. -1.91e+04. In the year 2011, what is the difference between the Number of enrolments of both sexes of Caribbean small states and Number of enrolments of both sexes of Mauritius?
Provide a succinct answer. 4.77e+05. In the year 2011, what is the difference between the Number of enrolments of both sexes of Equatorial Guinea and Number of enrolments of both sexes of Guinea?
Provide a short and direct response. -5.78e+05. In the year 2011, what is the difference between the Number of enrolments of both sexes in Equatorial Guinea and Number of enrolments of both sexes in Mauritius?
Offer a terse response. -8.11e+04. In the year 2011, what is the difference between the Number of enrolments of both sexes of Guinea and Number of enrolments of both sexes of Mauritius?
Offer a terse response. 4.97e+05. What is the ratio of the Number of enrolments of both sexes in Equatorial Guinea in 1994 to that in 1999?
Offer a very short reply. 0.77. What is the ratio of the Number of enrolments of both sexes in Guinea in 1994 to that in 1999?
Offer a very short reply. 0.65. What is the ratio of the Number of enrolments of both sexes in Mauritius in 1994 to that in 1999?
Your answer should be compact. 0.94. What is the ratio of the Number of enrolments of both sexes in Caribbean small states in 1994 to that in 2000?
Your answer should be compact. 0.99. What is the ratio of the Number of enrolments of both sexes in Equatorial Guinea in 1994 to that in 2000?
Ensure brevity in your answer.  0.74. What is the ratio of the Number of enrolments of both sexes in Guinea in 1994 to that in 2000?
Provide a succinct answer. 0.55. What is the ratio of the Number of enrolments of both sexes in Mauritius in 1994 to that in 2000?
Give a very brief answer. 0.94. What is the ratio of the Number of enrolments of both sexes in Caribbean small states in 1994 to that in 2001?
Provide a succinct answer. 0.98. What is the ratio of the Number of enrolments of both sexes of Equatorial Guinea in 1994 to that in 2001?
Offer a very short reply. 0.78. What is the ratio of the Number of enrolments of both sexes of Guinea in 1994 to that in 2001?
Your answer should be compact. 0.47. What is the ratio of the Number of enrolments of both sexes of Mauritius in 1994 to that in 2001?
Your answer should be compact. 0.92. What is the ratio of the Number of enrolments of both sexes of Caribbean small states in 1994 to that in 2002?
Give a very brief answer. 0.98. What is the ratio of the Number of enrolments of both sexes in Equatorial Guinea in 1994 to that in 2002?
Provide a succinct answer. 0.73. What is the ratio of the Number of enrolments of both sexes in Guinea in 1994 to that in 2002?
Offer a terse response. 0.4. What is the ratio of the Number of enrolments of both sexes of Mauritius in 1994 to that in 2002?
Your answer should be compact. 0.9. What is the ratio of the Number of enrolments of both sexes in Caribbean small states in 1994 to that in 2005?
Offer a very short reply. 0.96. What is the ratio of the Number of enrolments of both sexes of Equatorial Guinea in 1994 to that in 2005?
Keep it short and to the point. 0.6. What is the ratio of the Number of enrolments of both sexes of Guinea in 1994 to that in 2005?
Your answer should be compact. 0.26. What is the ratio of the Number of enrolments of both sexes in Mauritius in 1994 to that in 2005?
Your answer should be very brief. 0.81. What is the ratio of the Number of enrolments of both sexes of Caribbean small states in 1994 to that in 2011?
Provide a short and direct response. 0.92. What is the ratio of the Number of enrolments of both sexes in Equatorial Guinea in 1994 to that in 2011?
Provide a succinct answer. 0.42. What is the ratio of the Number of enrolments of both sexes of Guinea in 1994 to that in 2011?
Your response must be concise. 0.18. What is the ratio of the Number of enrolments of both sexes in Mauritius in 1994 to that in 2011?
Keep it short and to the point. 0.78. What is the ratio of the Number of enrolments of both sexes in Caribbean small states in 1999 to that in 2000?
Give a very brief answer. 0.99. What is the ratio of the Number of enrolments of both sexes of Equatorial Guinea in 1999 to that in 2000?
Your answer should be compact. 0.96. What is the ratio of the Number of enrolments of both sexes in Guinea in 1999 to that in 2000?
Provide a succinct answer. 0.84. What is the ratio of the Number of enrolments of both sexes of Caribbean small states in 1999 to that in 2001?
Offer a very short reply. 0.99. What is the ratio of the Number of enrolments of both sexes in Equatorial Guinea in 1999 to that in 2001?
Offer a terse response. 1.01. What is the ratio of the Number of enrolments of both sexes of Guinea in 1999 to that in 2001?
Keep it short and to the point. 0.71. What is the ratio of the Number of enrolments of both sexes of Mauritius in 1999 to that in 2001?
Provide a succinct answer. 0.97. What is the ratio of the Number of enrolments of both sexes of Caribbean small states in 1999 to that in 2002?
Offer a very short reply. 0.99. What is the ratio of the Number of enrolments of both sexes of Equatorial Guinea in 1999 to that in 2002?
Provide a short and direct response. 0.95. What is the ratio of the Number of enrolments of both sexes in Guinea in 1999 to that in 2002?
Keep it short and to the point. 0.61. What is the ratio of the Number of enrolments of both sexes in Mauritius in 1999 to that in 2002?
Keep it short and to the point. 0.95. What is the ratio of the Number of enrolments of both sexes of Caribbean small states in 1999 to that in 2005?
Give a very brief answer. 0.97. What is the ratio of the Number of enrolments of both sexes in Equatorial Guinea in 1999 to that in 2005?
Your response must be concise. 0.78. What is the ratio of the Number of enrolments of both sexes of Guinea in 1999 to that in 2005?
Provide a short and direct response. 0.4. What is the ratio of the Number of enrolments of both sexes in Mauritius in 1999 to that in 2005?
Offer a terse response. 0.86. What is the ratio of the Number of enrolments of both sexes in Caribbean small states in 1999 to that in 2011?
Your answer should be compact. 0.92. What is the ratio of the Number of enrolments of both sexes in Equatorial Guinea in 1999 to that in 2011?
Your answer should be compact. 0.55. What is the ratio of the Number of enrolments of both sexes of Guinea in 1999 to that in 2011?
Offer a terse response. 0.27. What is the ratio of the Number of enrolments of both sexes of Mauritius in 1999 to that in 2011?
Give a very brief answer. 0.83. What is the ratio of the Number of enrolments of both sexes of Equatorial Guinea in 2000 to that in 2001?
Provide a short and direct response. 1.05. What is the ratio of the Number of enrolments of both sexes in Guinea in 2000 to that in 2001?
Your answer should be compact. 0.85. What is the ratio of the Number of enrolments of both sexes in Mauritius in 2000 to that in 2001?
Provide a short and direct response. 0.98. What is the ratio of the Number of enrolments of both sexes in Caribbean small states in 2000 to that in 2002?
Ensure brevity in your answer.  1. What is the ratio of the Number of enrolments of both sexes in Equatorial Guinea in 2000 to that in 2002?
Offer a very short reply. 0.99. What is the ratio of the Number of enrolments of both sexes of Guinea in 2000 to that in 2002?
Give a very brief answer. 0.73. What is the ratio of the Number of enrolments of both sexes of Mauritius in 2000 to that in 2002?
Offer a very short reply. 0.96. What is the ratio of the Number of enrolments of both sexes in Equatorial Guinea in 2000 to that in 2005?
Make the answer very short. 0.81. What is the ratio of the Number of enrolments of both sexes in Guinea in 2000 to that in 2005?
Your response must be concise. 0.47. What is the ratio of the Number of enrolments of both sexes in Mauritius in 2000 to that in 2005?
Provide a short and direct response. 0.87. What is the ratio of the Number of enrolments of both sexes of Caribbean small states in 2000 to that in 2011?
Your response must be concise. 0.93. What is the ratio of the Number of enrolments of both sexes of Equatorial Guinea in 2000 to that in 2011?
Keep it short and to the point. 0.57. What is the ratio of the Number of enrolments of both sexes in Guinea in 2000 to that in 2011?
Your answer should be compact. 0.32. What is the ratio of the Number of enrolments of both sexes of Mauritius in 2000 to that in 2011?
Your answer should be compact. 0.83. What is the ratio of the Number of enrolments of both sexes of Caribbean small states in 2001 to that in 2002?
Make the answer very short. 1. What is the ratio of the Number of enrolments of both sexes in Equatorial Guinea in 2001 to that in 2002?
Your answer should be compact. 0.94. What is the ratio of the Number of enrolments of both sexes of Guinea in 2001 to that in 2002?
Your response must be concise. 0.86. What is the ratio of the Number of enrolments of both sexes of Mauritius in 2001 to that in 2002?
Ensure brevity in your answer.  0.98. What is the ratio of the Number of enrolments of both sexes of Caribbean small states in 2001 to that in 2005?
Your response must be concise. 0.98. What is the ratio of the Number of enrolments of both sexes of Equatorial Guinea in 2001 to that in 2005?
Give a very brief answer. 0.77. What is the ratio of the Number of enrolments of both sexes in Guinea in 2001 to that in 2005?
Make the answer very short. 0.56. What is the ratio of the Number of enrolments of both sexes of Mauritius in 2001 to that in 2005?
Your answer should be compact. 0.89. What is the ratio of the Number of enrolments of both sexes of Caribbean small states in 2001 to that in 2011?
Your answer should be very brief. 0.94. What is the ratio of the Number of enrolments of both sexes in Equatorial Guinea in 2001 to that in 2011?
Offer a very short reply. 0.54. What is the ratio of the Number of enrolments of both sexes in Guinea in 2001 to that in 2011?
Provide a succinct answer. 0.38. What is the ratio of the Number of enrolments of both sexes of Mauritius in 2001 to that in 2011?
Offer a terse response. 0.85. What is the ratio of the Number of enrolments of both sexes in Caribbean small states in 2002 to that in 2005?
Your response must be concise. 0.98. What is the ratio of the Number of enrolments of both sexes of Equatorial Guinea in 2002 to that in 2005?
Keep it short and to the point. 0.82. What is the ratio of the Number of enrolments of both sexes of Guinea in 2002 to that in 2005?
Give a very brief answer. 0.65. What is the ratio of the Number of enrolments of both sexes of Mauritius in 2002 to that in 2005?
Your answer should be very brief. 0.9. What is the ratio of the Number of enrolments of both sexes of Caribbean small states in 2002 to that in 2011?
Offer a terse response. 0.94. What is the ratio of the Number of enrolments of both sexes of Equatorial Guinea in 2002 to that in 2011?
Provide a short and direct response. 0.58. What is the ratio of the Number of enrolments of both sexes in Guinea in 2002 to that in 2011?
Keep it short and to the point. 0.44. What is the ratio of the Number of enrolments of both sexes in Mauritius in 2002 to that in 2011?
Give a very brief answer. 0.86. What is the ratio of the Number of enrolments of both sexes of Caribbean small states in 2005 to that in 2011?
Keep it short and to the point. 0.96. What is the ratio of the Number of enrolments of both sexes in Equatorial Guinea in 2005 to that in 2011?
Your answer should be very brief. 0.7. What is the ratio of the Number of enrolments of both sexes in Guinea in 2005 to that in 2011?
Provide a succinct answer. 0.68. What is the ratio of the Number of enrolments of both sexes of Mauritius in 2005 to that in 2011?
Your answer should be compact. 0.96. What is the difference between the highest and the second highest Number of enrolments of both sexes in Caribbean small states?
Your answer should be compact. 2.53e+04. What is the difference between the highest and the second highest Number of enrolments of both sexes of Equatorial Guinea?
Provide a succinct answer. 1.02e+04. What is the difference between the highest and the second highest Number of enrolments of both sexes of Guinea?
Make the answer very short. 1.96e+05. What is the difference between the highest and the second highest Number of enrolments of both sexes in Mauritius?
Your response must be concise. 5002. What is the difference between the highest and the lowest Number of enrolments of both sexes of Caribbean small states?
Ensure brevity in your answer.  4.88e+04. What is the difference between the highest and the lowest Number of enrolments of both sexes of Equatorial Guinea?
Offer a terse response. 1.97e+04. What is the difference between the highest and the lowest Number of enrolments of both sexes of Guinea?
Offer a terse response. 5.03e+05. What is the difference between the highest and the lowest Number of enrolments of both sexes in Mauritius?
Provide a succinct answer. 2.57e+04. 